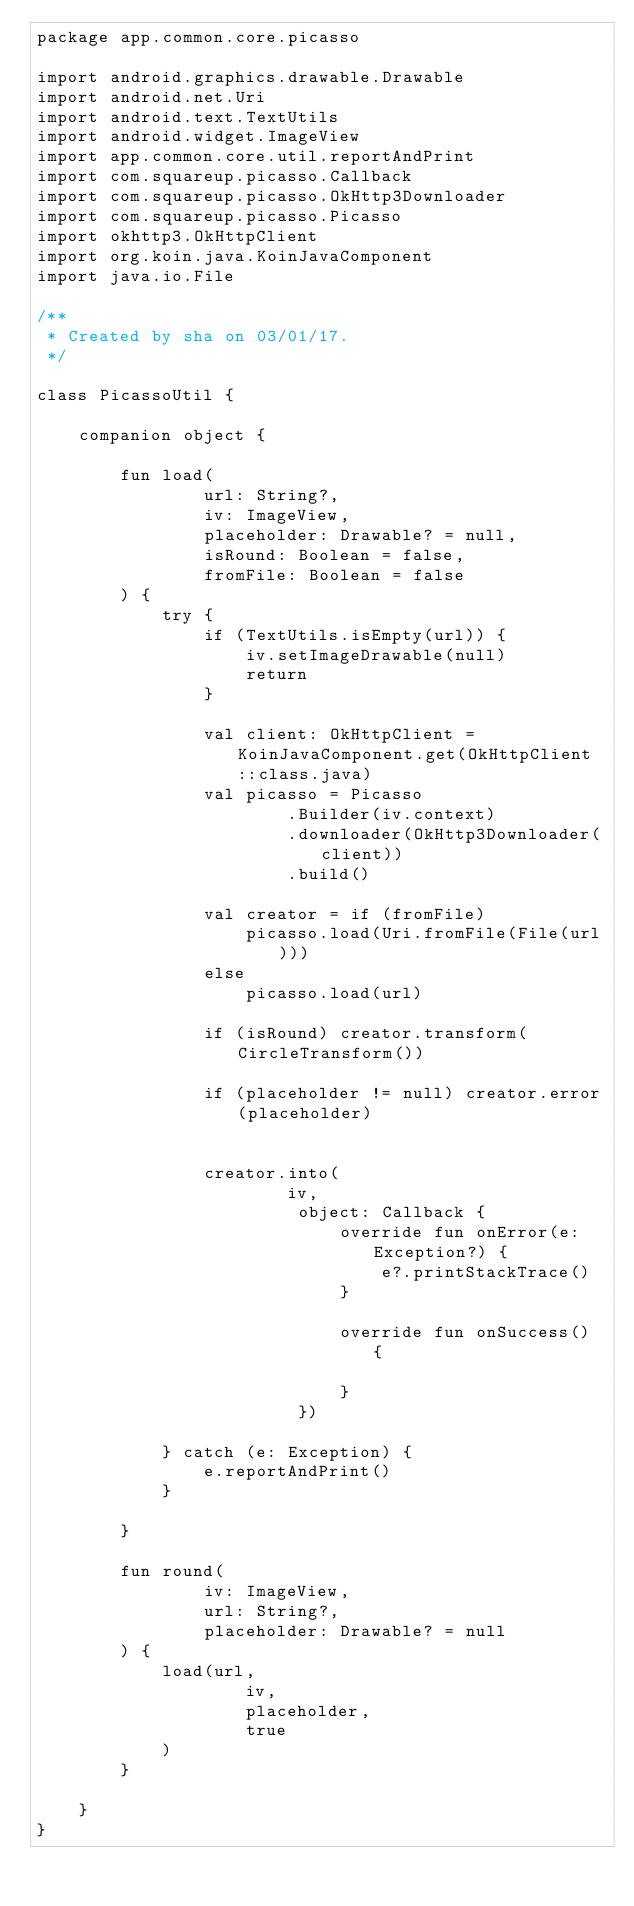Convert code to text. <code><loc_0><loc_0><loc_500><loc_500><_Kotlin_>package app.common.core.picasso

import android.graphics.drawable.Drawable
import android.net.Uri
import android.text.TextUtils
import android.widget.ImageView
import app.common.core.util.reportAndPrint
import com.squareup.picasso.Callback
import com.squareup.picasso.OkHttp3Downloader
import com.squareup.picasso.Picasso
import okhttp3.OkHttpClient
import org.koin.java.KoinJavaComponent
import java.io.File

/**
 * Created by sha on 03/01/17.
 */

class PicassoUtil {

    companion object {

        fun load(
                url: String?,
                iv: ImageView,
                placeholder: Drawable? = null,
                isRound: Boolean = false,
                fromFile: Boolean = false
        ) {
            try {
                if (TextUtils.isEmpty(url)) {
                    iv.setImageDrawable(null)
                    return
                }

                val client: OkHttpClient = KoinJavaComponent.get(OkHttpClient::class.java)
                val picasso = Picasso
                        .Builder(iv.context)
                        .downloader(OkHttp3Downloader(client))
                        .build()

                val creator = if (fromFile)
                    picasso.load(Uri.fromFile(File(url)))
                else
                    picasso.load(url)

                if (isRound) creator.transform(CircleTransform())

                if (placeholder != null) creator.error(placeholder)


                creator.into(
                        iv,
                         object: Callback {
                             override fun onError(e: Exception?) {
                                 e?.printStackTrace()
                             }

                             override fun onSuccess() {

                             }
                         })

            } catch (e: Exception) {
                e.reportAndPrint()
            }

        }

        fun round(
                iv: ImageView,
                url: String?,
                placeholder: Drawable? = null
        ) {
            load(url,
                    iv,
                    placeholder,
                    true
            )
        }

    }
}
</code> 